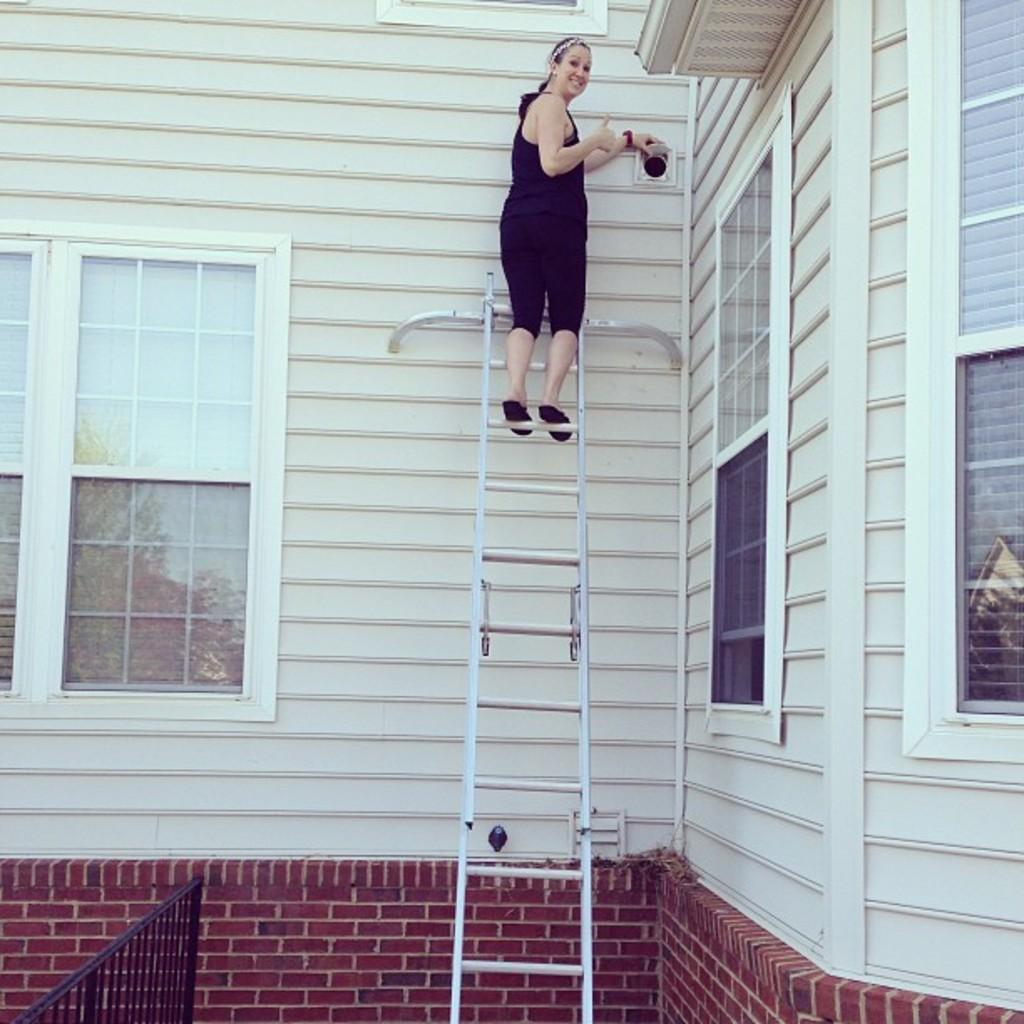What type of structure is in the image? There is a white building in the image. What features can be seen on the building? The building has windows. Who is present in the image? A woman is standing on the building. What is the woman wearing? The woman is wearing a black dress. What expression does the woman have? The woman has a smile on her face. How many watches can be seen on the woman's wrist in the image? There are no watches visible on the woman's wrist in the image. What color are the woman's eyes in the image? The woman's eye color is not mentioned in the provided facts, so it cannot be determined from the image. 